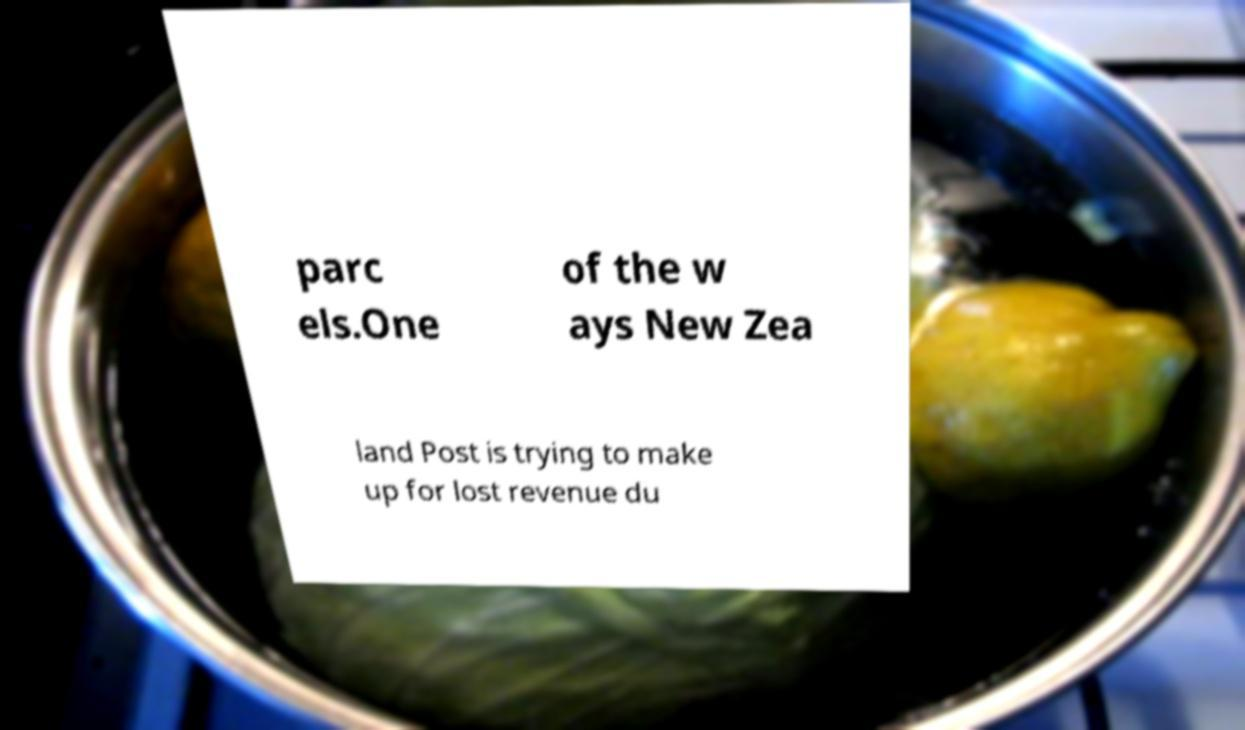What messages or text are displayed in this image? I need them in a readable, typed format. parc els.One of the w ays New Zea land Post is trying to make up for lost revenue du 